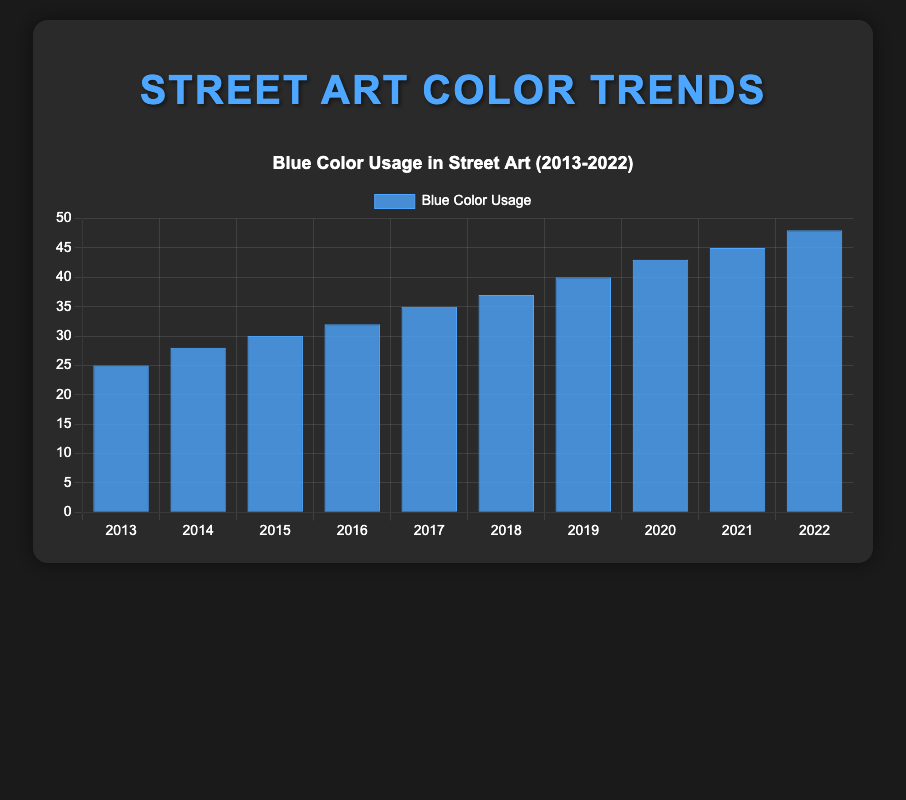What was the amount of Blue color used in 2020 and 2021 combined? The chart shows separate bars for each year. To find the combined amount, we look at the heights of the bars for 2020 and 2021. For 2020, Blue is 43, and for 2021, Blue is 45. Adding these together: 43 + 45 = 88.
Answer: 88 Which year had the highest usage of Blue color? We need to compare the heights of all the bars on the chart. The tallest bar corresponds to the year 2022. Therefore, 2022 had the highest usage of Blue color.
Answer: 2022 Between which two consecutive years was the increase in Blue color usage the greatest? To identify this, we calculate the difference in the Blue color usage between each consecutive year and find the maximum difference:
2014-2013: 28-25 = 3
2015-2014: 30-28 = 2
2016-2015: 32-30 = 2
2017-2016: 35-32 = 3
2018-2017: 37-35 = 2
2019-2018: 40-37 = 3
2020-2019: 43-40 = 3
2021-2020: 45-43 = 2
2022-2021: 48-45 = 3 
The largest increase was 3, occurring in years 2014-2013, 2017-2016, 2019-2018, and 2022-2021.
Answer: 2014-2013, 2017-2016, 2019-2018, 2022-2021 What is the average Blue color usage from 2019 to 2022? To calculate the average, we sum the values for Blue from 2019, 2020, 2021, and 2022, then divide by 4.
(40 + 43 + 45 + 48) / 4 = 176 / 4 = 44
Answer: 44 In which year did the usage of Blue color first exceed 35? We look at each year and check when Blue color usage first surpasses 35. The bar in 2017 indicates 35, and 2018 indicates 37. Therefore, it first exceeded 35 in 2018.
Answer: 2018 